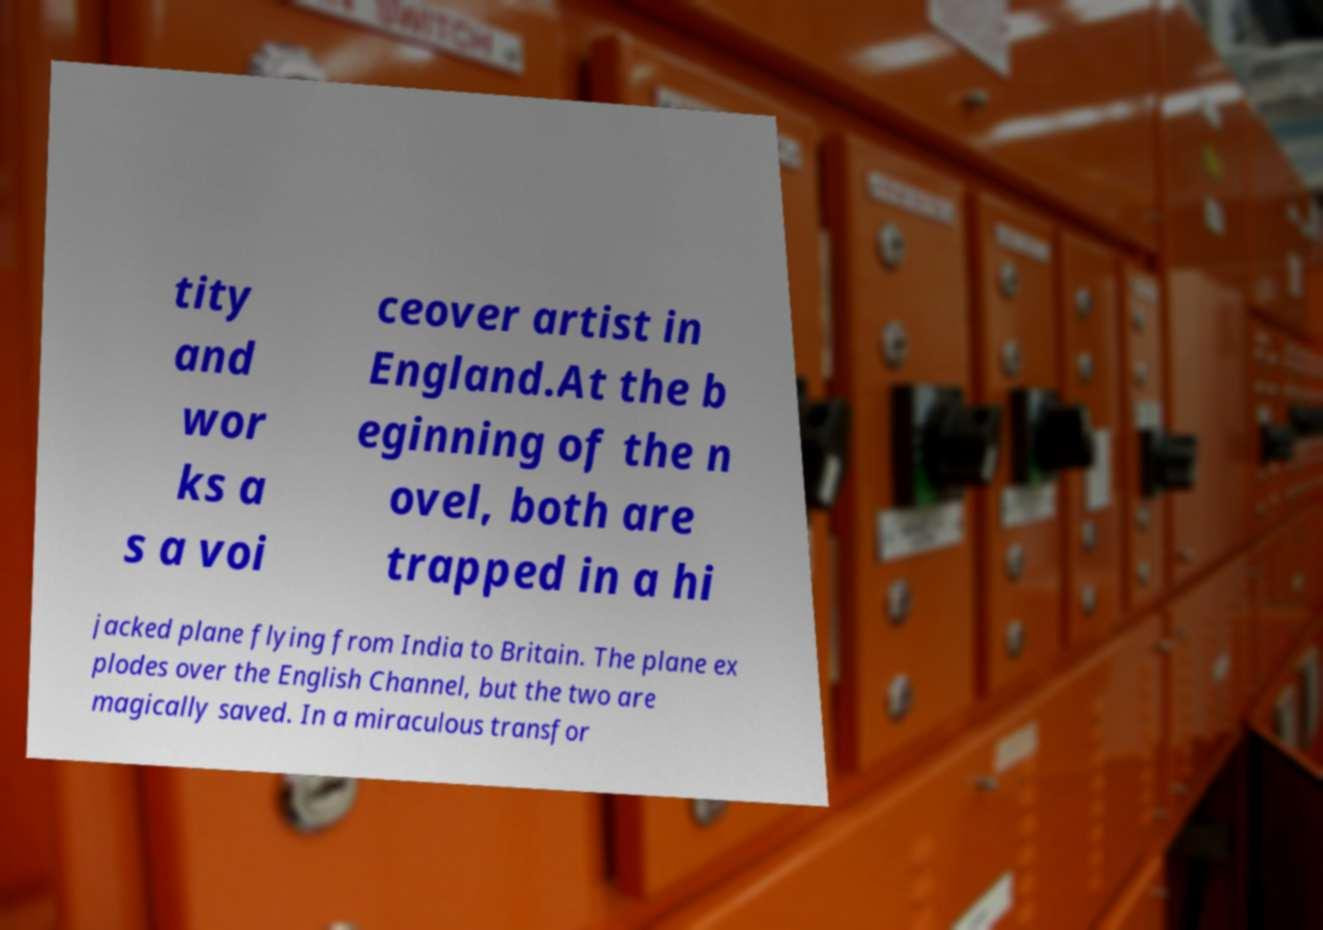Please read and relay the text visible in this image. What does it say? tity and wor ks a s a voi ceover artist in England.At the b eginning of the n ovel, both are trapped in a hi jacked plane flying from India to Britain. The plane ex plodes over the English Channel, but the two are magically saved. In a miraculous transfor 